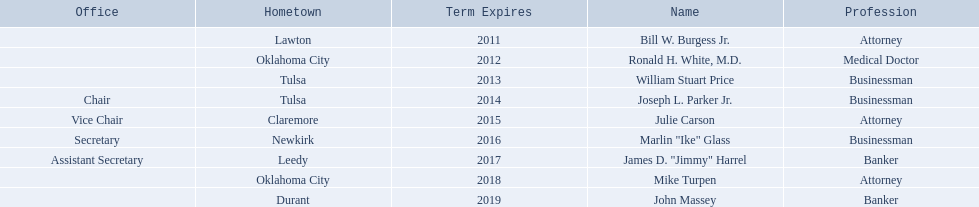Where is bill w. burgess jr. from? Lawton. Where is price and parker from? Tulsa. Who is from the same state as white? Mike Turpen. 